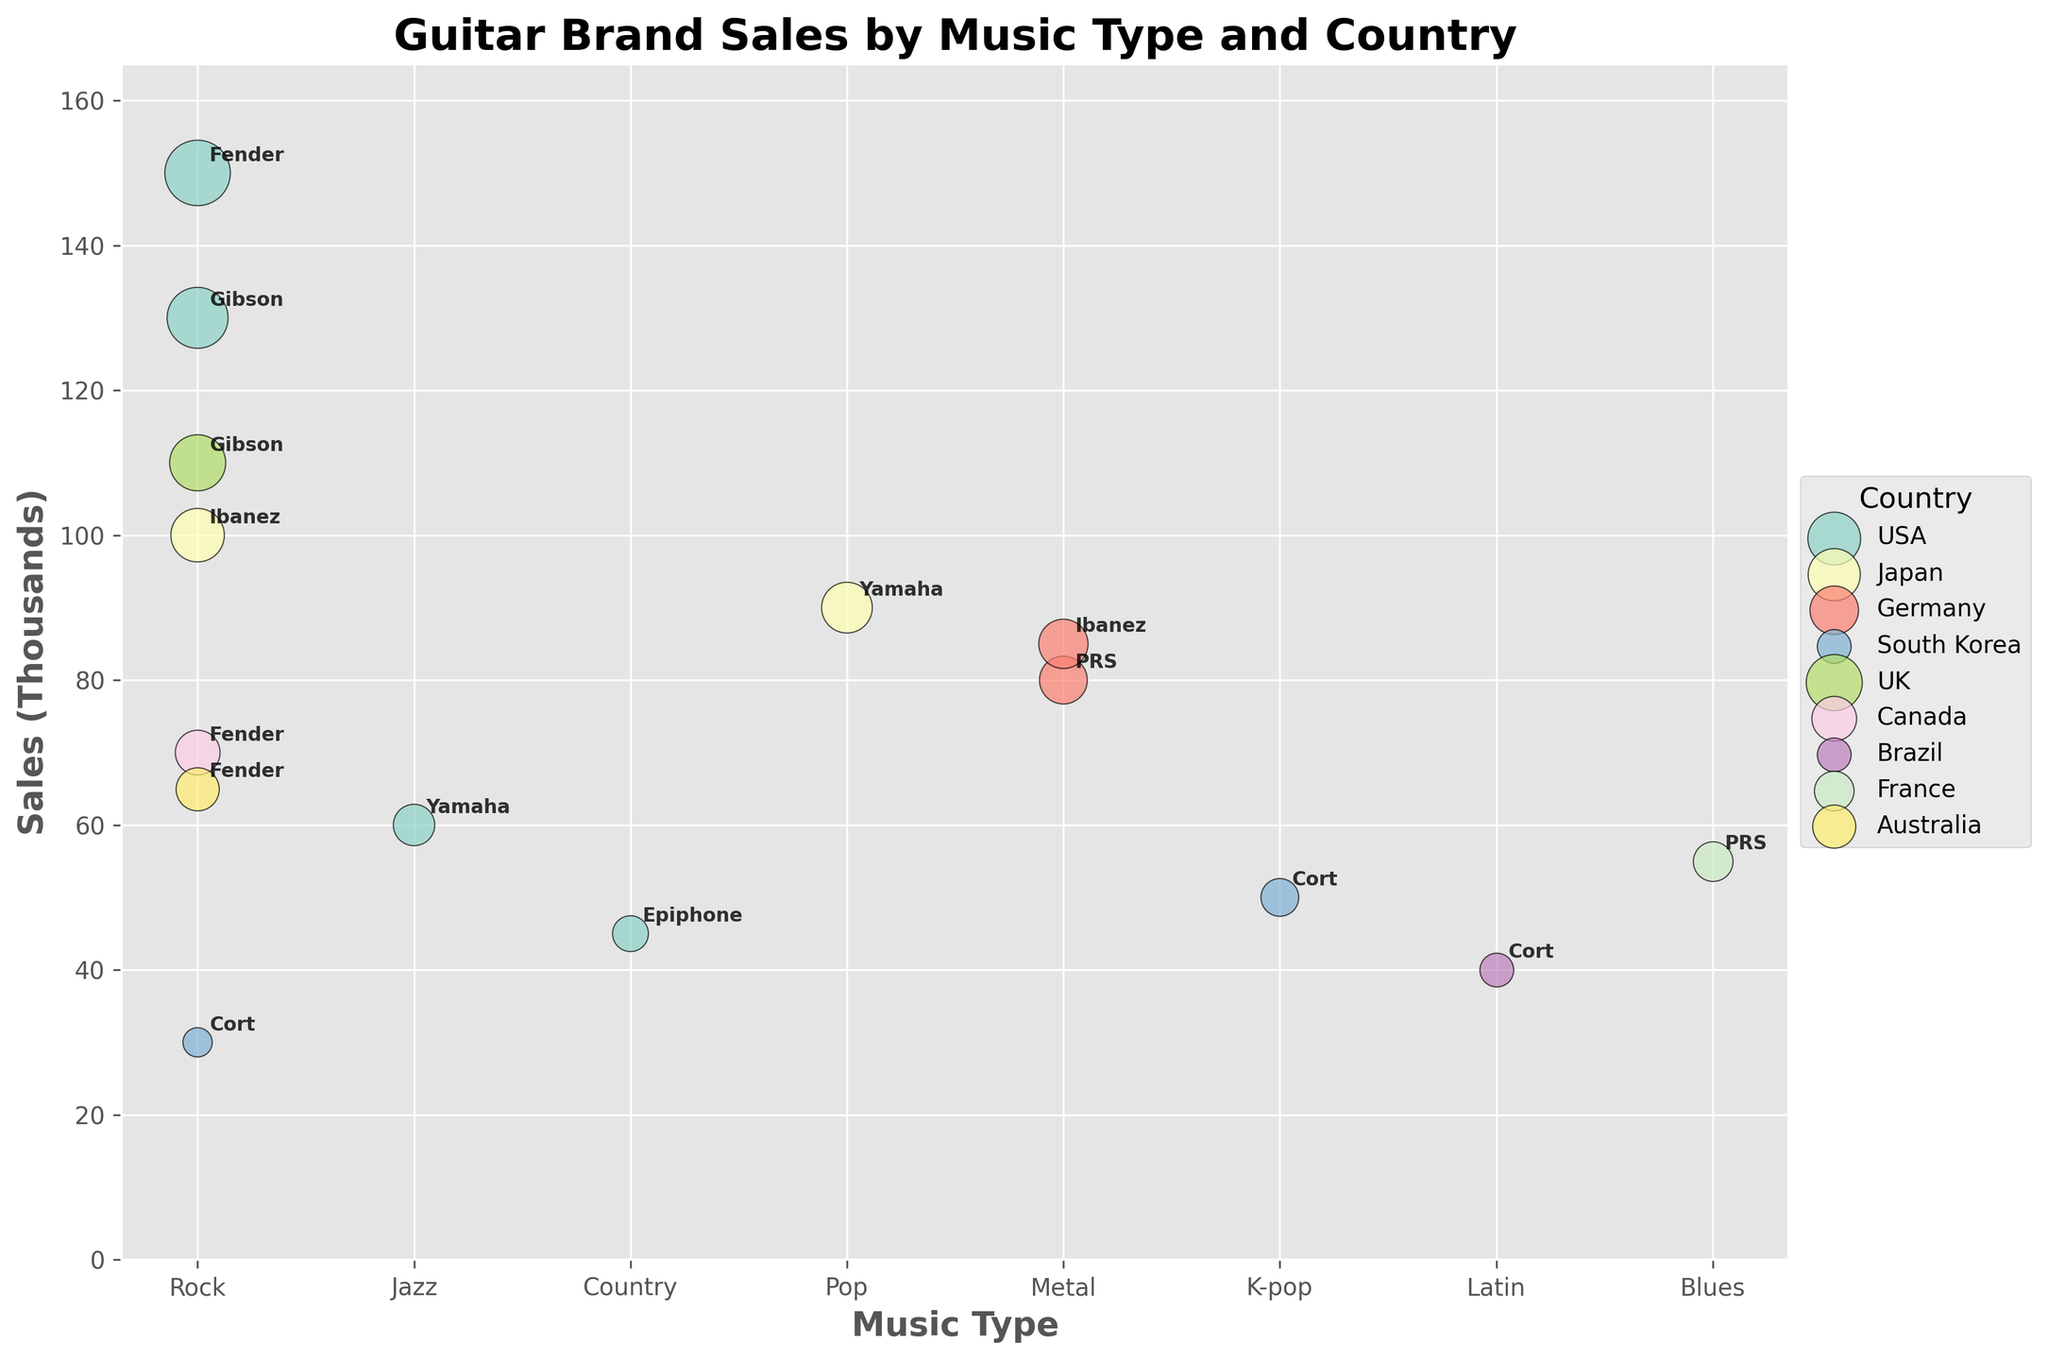What is the title of the plot? The title of the plot is displayed at the top center of the figure and reads "Guitar Brand Sales by Music Type and Country."
Answer: Guitar Brand Sales by Music Type and Country Which country has the most guitar brands represented in the plot? By looking at the plot, you can count the number of different brands for each country. USA has the most amount with 5 brands: Fender, Gibson, Yamaha, Epiphone, and one more Fender.
Answer: USA What is the average sales of guitar brands in the USA for Rock music? In the plot, locate the points that correspond to 'USA' and 'Rock' music type. Sum the sales values which are 150 (Fender), 130 (Gibson) and 70 (Fender), then divide by the number of points, which is 3: (150 + 130 + 70) / 3 = 116.67.
Answer: 116.67 Which brand has the highest sales in the plot? Scan the plot for the highest point on the Sales (Thousands) axis. Fender, representing USA and Rock music, is at 150.
Answer: Fender Compare the average sales of guitars for Rock music between USA and Japan. Which country has higher average sales? Calculate the average sales for the USA (Rock): (150 + 130 + 70) / 3 = 116.67. For Japan (Rock): 100. Therefore, USA has higher average sales.
Answer: USA How many guitar brands are associated with Rock music in total? Look for all points labeled with 'Rock' under the Music Type axis. There are 7 points corresponding to Fender (USA), Gibson (USA), Ibanez (Japan), Fender (Canada), Gibson (UK), Fender (Australia), and Cort (South Korea).
Answer: 7 Which country has the largest bubble size for Jazz music? Locate the point corresponding to 'Jazz' in the Music Type axis and 'USA' in the Country legend. The bubble size is 60 for the brand Yamaha in the USA.
Answer: USA Which has more sales: PRS in France for Blues music, or Cort in South Korea for K-pop? Compare the sales data points: PRS in France (Blues) has 55, and Cort in South Korea (K-pop) has 50. 55 is greater than 50.
Answer: PRS in France for Blues music Describe how sales for Latin music compare to sales for Country music. Identify the data points for both music types: Cort (Brazil) for Latin music has sales of 40, and Epiphone (USA) for Country music has sales of 45. Therefore, Country has slightly higher sales.
Answer: Country has higher sales What are the sales differences between the highest and lowest selling brands? Identify the highest selling brand (Fender, 150 for USA Rock) and the lowest selling brand (Cort, 30 for South Korea Rock). The difference is 150 - 30 = 120.
Answer: 120 